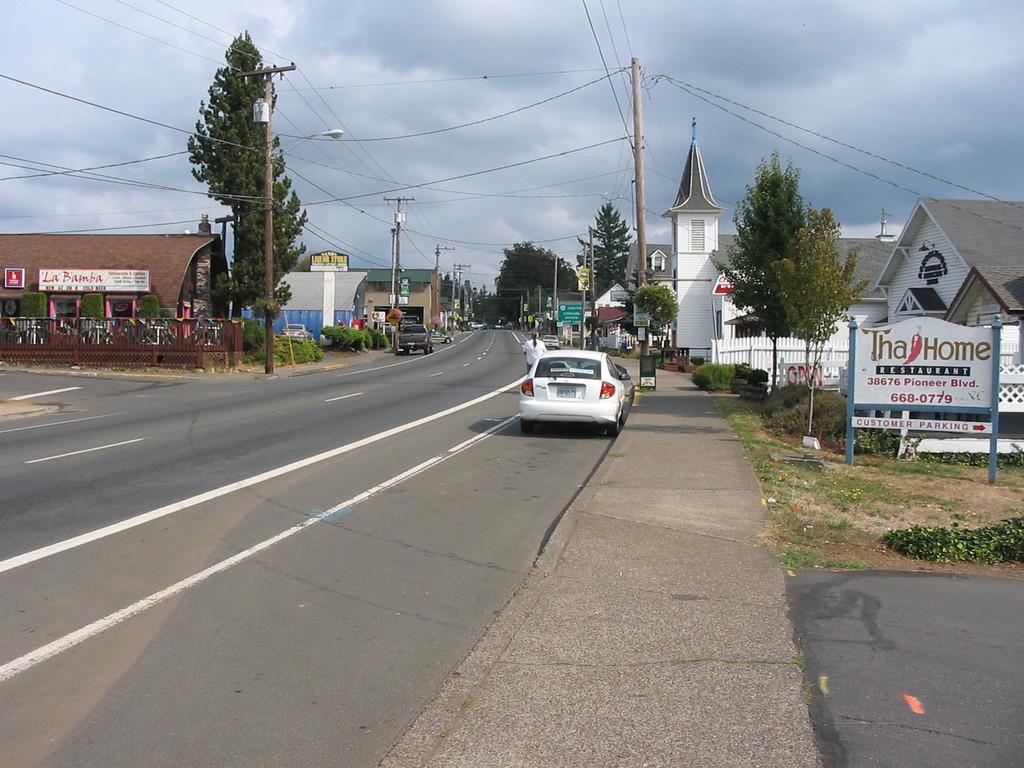Can you describe this image briefly? In the foreground of this image, there is a road and in the middle, there are trees, few vehicles on the road, side path, poles, cables and buildings. On the right, there is a board on the land. At the top, there is the sky. 